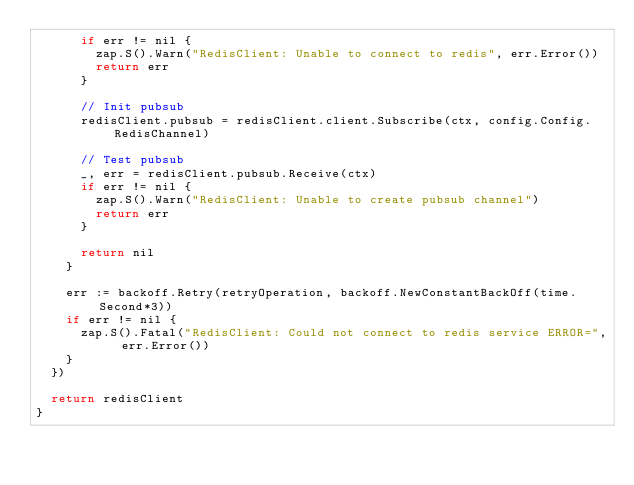Convert code to text. <code><loc_0><loc_0><loc_500><loc_500><_Go_>			if err != nil {
				zap.S().Warn("RedisClient: Unable to connect to redis", err.Error())
				return err
			}

			// Init pubsub
			redisClient.pubsub = redisClient.client.Subscribe(ctx, config.Config.RedisChannel)

			// Test pubsub
			_, err = redisClient.pubsub.Receive(ctx)
			if err != nil {
				zap.S().Warn("RedisClient: Unable to create pubsub channel")
				return err
			}

			return nil
		}

		err := backoff.Retry(retryOperation, backoff.NewConstantBackOff(time.Second*3))
		if err != nil {
			zap.S().Fatal("RedisClient: Could not connect to redis service ERROR=", err.Error())
		}
	})

	return redisClient
}
</code> 